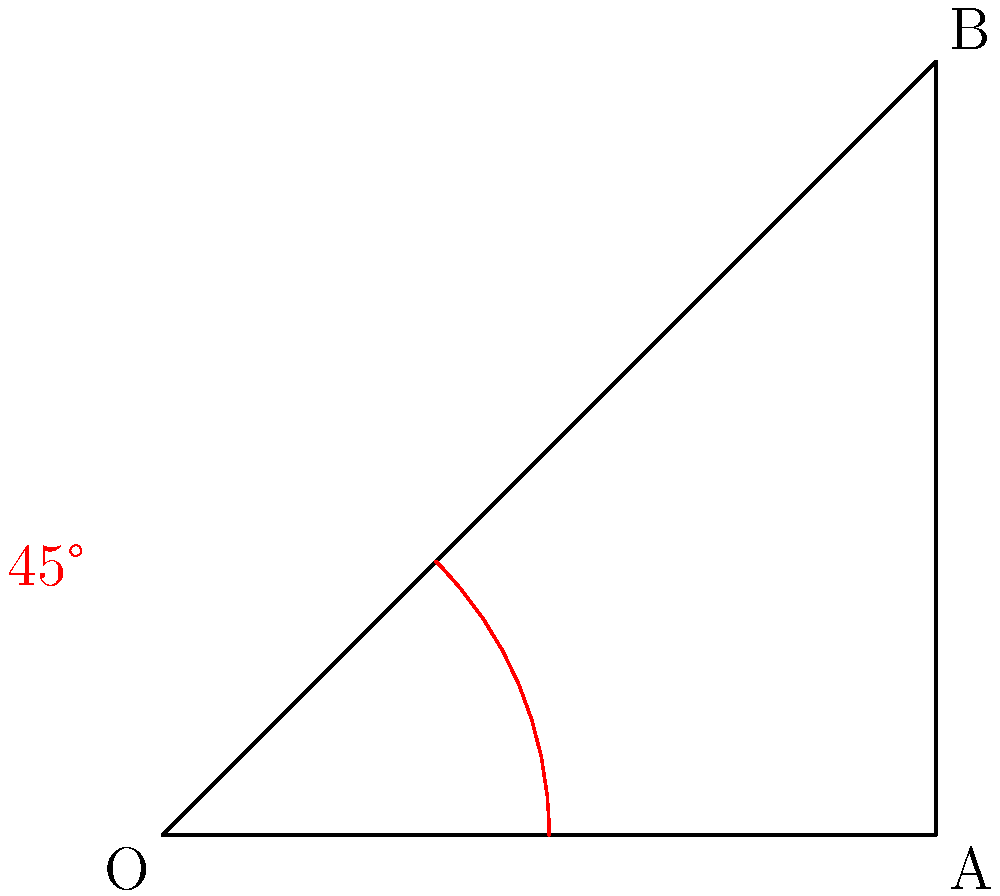In an SVG design, you need to rotate a square element clockwise so that its diagonal becomes vertical. Given that the square's initial position has its bottom side horizontal, what should be the angle of rotation in degrees? To solve this problem, let's follow these steps:

1. Recognize that the square's diagonal forms a 45-degree angle with its sides when in its initial position.

2. Understand that we want the diagonal to be vertical, which means it should form a 90-degree angle with the horizontal.

3. Calculate the required rotation:
   - The angle we need to rotate is the difference between the final position (90 degrees) and the initial position (45 degrees).
   - Rotation angle = 90° - 45° = 45°

4. In SVG, positive rotation values indicate clockwise rotation, which matches our requirement.

Therefore, we need to rotate the square 45 degrees clockwise to make its diagonal vertical.
Answer: 45° 